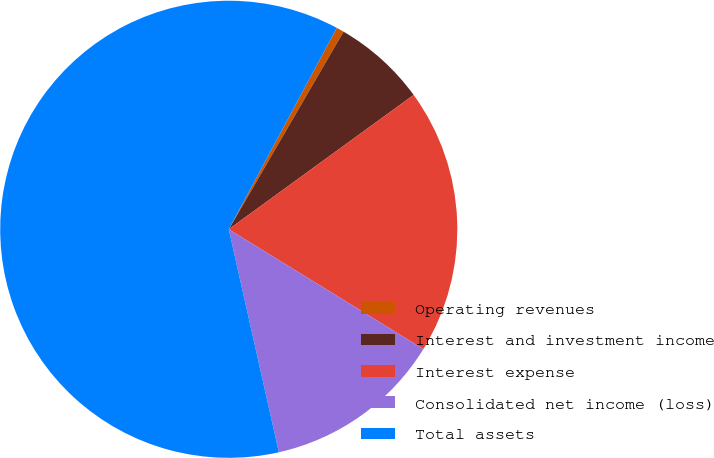<chart> <loc_0><loc_0><loc_500><loc_500><pie_chart><fcel>Operating revenues<fcel>Interest and investment income<fcel>Interest expense<fcel>Consolidated net income (loss)<fcel>Total assets<nl><fcel>0.54%<fcel>6.62%<fcel>18.78%<fcel>12.7%<fcel>61.35%<nl></chart> 